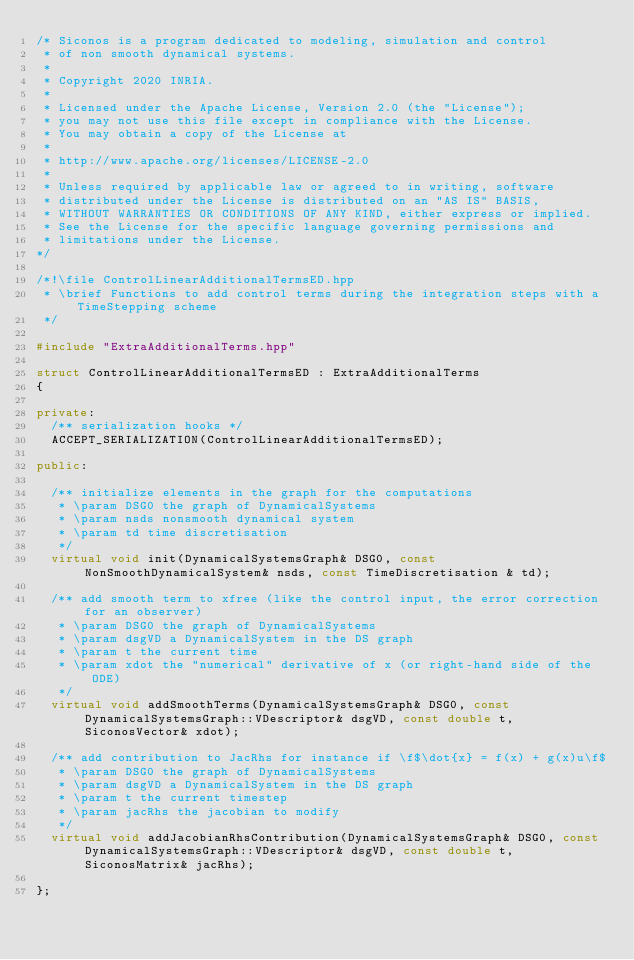<code> <loc_0><loc_0><loc_500><loc_500><_C++_>/* Siconos is a program dedicated to modeling, simulation and control
 * of non smooth dynamical systems.
 *
 * Copyright 2020 INRIA.
 *
 * Licensed under the Apache License, Version 2.0 (the "License");
 * you may not use this file except in compliance with the License.
 * You may obtain a copy of the License at
 *
 * http://www.apache.org/licenses/LICENSE-2.0
 *
 * Unless required by applicable law or agreed to in writing, software
 * distributed under the License is distributed on an "AS IS" BASIS,
 * WITHOUT WARRANTIES OR CONDITIONS OF ANY KIND, either express or implied.
 * See the License for the specific language governing permissions and
 * limitations under the License.
*/

/*!\file ControlLinearAdditionalTermsED.hpp
 * \brief Functions to add control terms during the integration steps with a TimeStepping scheme
 */

#include "ExtraAdditionalTerms.hpp"

struct ControlLinearAdditionalTermsED : ExtraAdditionalTerms
{

private:
  /** serialization hooks */
  ACCEPT_SERIALIZATION(ControlLinearAdditionalTermsED);

public:

  /** initialize elements in the graph for the computations
   * \param DSG0 the graph of DynamicalSystems
   * \param nsds nonsmooth dynamical system  
   * \param td time discretisation
   */
  virtual void init(DynamicalSystemsGraph& DSG0, const NonSmoothDynamicalSystem& nsds, const TimeDiscretisation & td);

  /** add smooth term to xfree (like the control input, the error correction for an observer)
   * \param DSG0 the graph of DynamicalSystems
   * \param dsgVD a DynamicalSystem in the DS graph
   * \param t the current time
   * \param xdot the "numerical" derivative of x (or right-hand side of the ODE)
   */
  virtual void addSmoothTerms(DynamicalSystemsGraph& DSG0, const DynamicalSystemsGraph::VDescriptor& dsgVD, const double t, SiconosVector& xdot);

  /** add contribution to JacRhs for instance if \f$\dot{x} = f(x) + g(x)u\f$
   * \param DSG0 the graph of DynamicalSystems
   * \param dsgVD a DynamicalSystem in the DS graph
   * \param t the current timestep
   * \param jacRhs the jacobian to modify
   */
  virtual void addJacobianRhsContribution(DynamicalSystemsGraph& DSG0, const DynamicalSystemsGraph::VDescriptor& dsgVD, const double t, SiconosMatrix& jacRhs);

};
</code> 